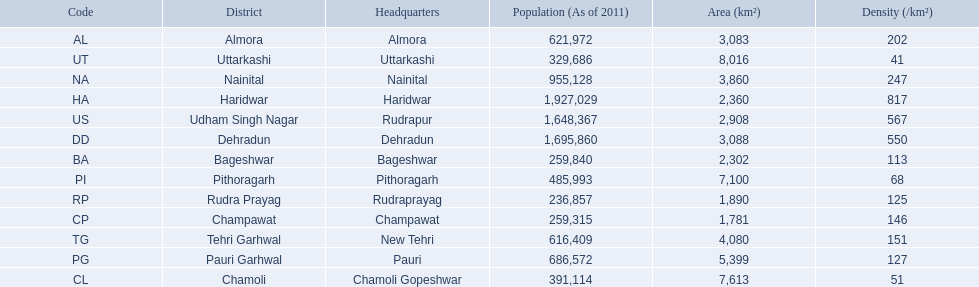What are all the districts? Almora, Bageshwar, Chamoli, Champawat, Dehradun, Haridwar, Nainital, Pauri Garhwal, Pithoragarh, Rudra Prayag, Tehri Garhwal, Udham Singh Nagar, Uttarkashi. And their densities? 202, 113, 51, 146, 550, 817, 247, 127, 68, 125, 151, 567, 41. Now, which district's density is 51? Chamoli. 